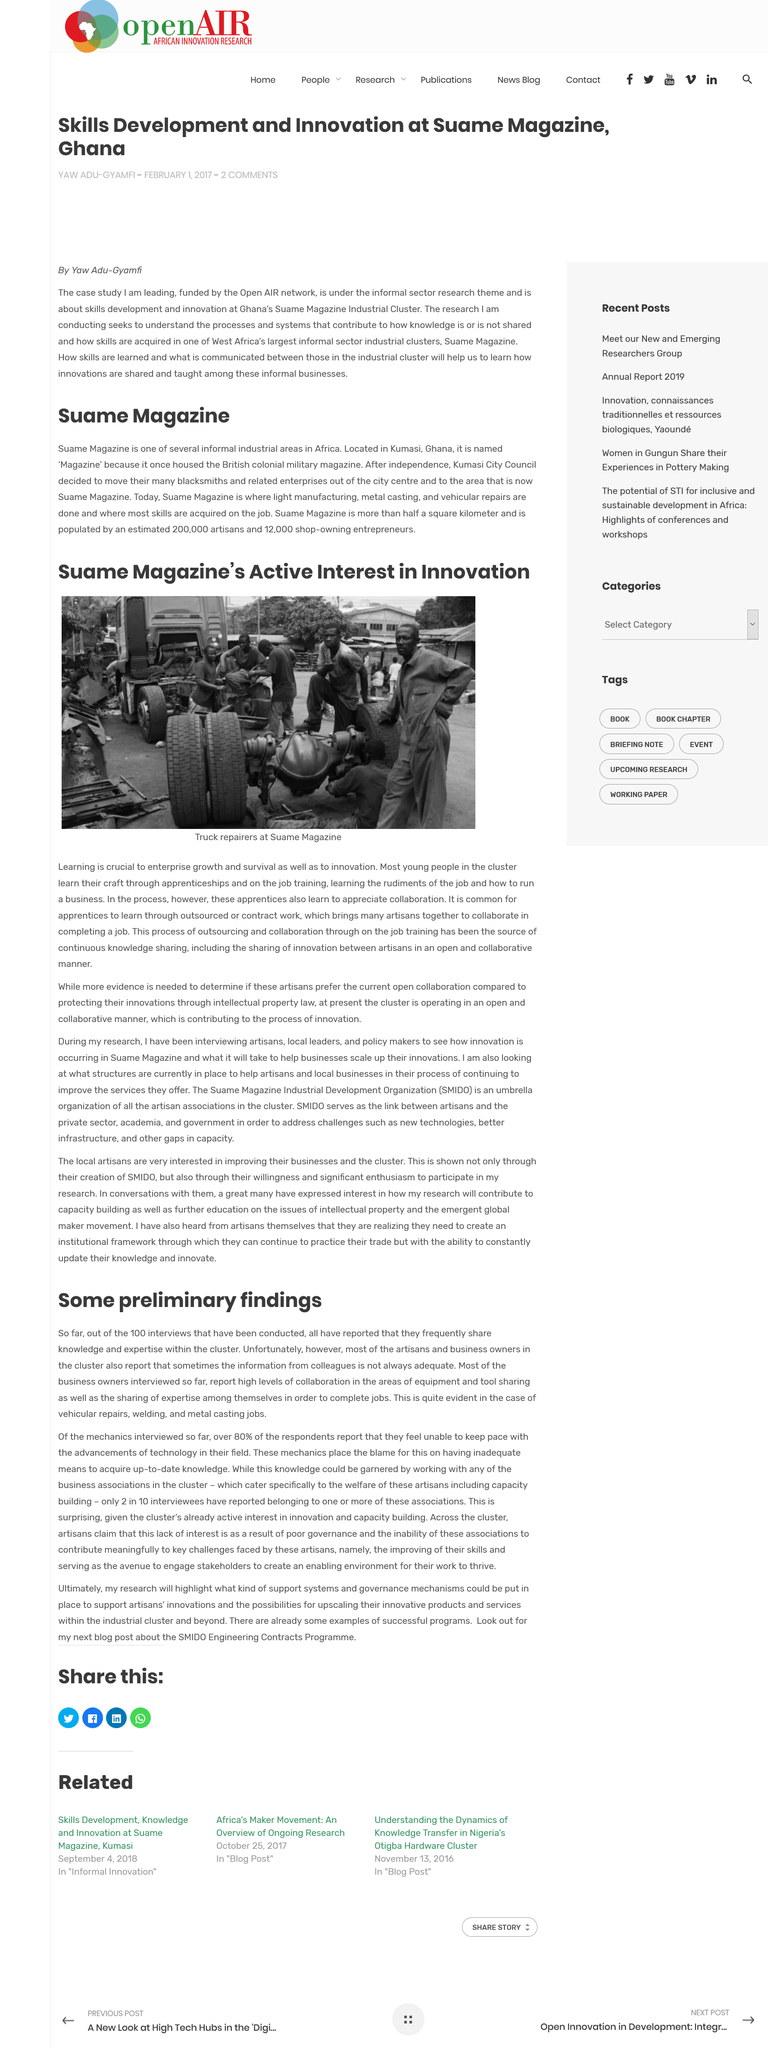Highlight a few significant elements in this photo. The Suame Magazine currently has industrial processes that include light manufacturing, metal casting, and vehicular repairs. The people in the image are truck repairers, whose job it is to maintain and repair heavy-duty vehicles such as trucks. Apprentices are required to work as a team to complete a job, as collaboration is a common occurrence in the completion of tasks. According to most artisans and business owners in the cluster, the information reported is often inadequate, and they report that the information from colleagues is not always reliable. Suame Magazine was named "Magazine" because it used to house the British Colonial Military Magazine. 